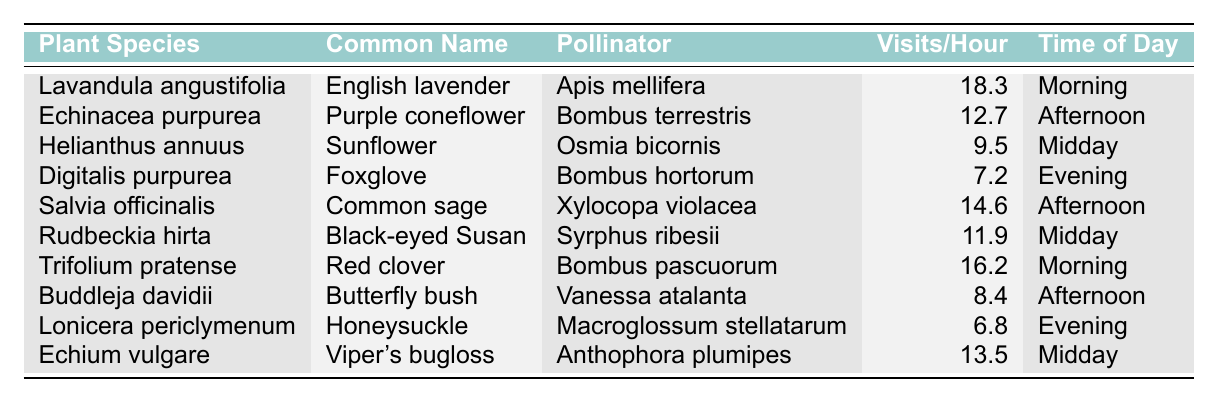What is the common name of the pollinator that visits Lavandula angustifolia? According to the table, the plant species Lavandula angustifolia, which is commonly known as English lavender, is visited by the pollinator Apis mellifera.
Answer: English lavender Which plant species has the highest visitation frequency? By examining the "Visits/Hour" column, Lavandula angustifolia has the highest value at 18.3 visits per hour.
Answer: Lavandula angustifolia How many visits per hour does Digitalis purpurea receive? The table lists Digitalis purpurea, or Foxglove, with a visitation frequency of 7.2 visits per hour.
Answer: 7.2 Are there any plants that are visited by Bombus species? The table indicates that both Echinacea purpurea (Bombus terrestris) and Trifolium pratense (Bombus pascuorum) are visited by Bombus species.
Answer: Yes What is the average number of visits per hour for the plants visited in the afternoon? The afternoon plants are Echinacea purpurea (12.7), Salvia officinalis (14.6), and Buddleja davidii (8.4). The sum is 12.7 + 14.6 + 8.4 = 35.7, and there are 3 plants, so the average is 35.7 / 3 = 11.9.
Answer: 11.9 Which time of day does Helianthus annuus receive pollinator visits? The table states that Helianthus annuus, or Sunflower, has pollinator visits recorded at midday.
Answer: Midday What is the difference in visitation frequency between Trifolium pratense and Digitalis purpurea? Trifolium pratense has 16.2 visits per hour and Digitalis purpurea has 7.2 visits per hour. The difference is calculated as 16.2 - 7.2 = 9.0.
Answer: 9.0 In the evening, which plant has the highest visitation frequency, and what is it? According to the table, Digitalis purpurea is the only specific plant listed for the evening with 7.2 visits per hour, thus it has the highest visitation frequency in that period.
Answer: Digitalis purpurea, 7.2 Does any plant have more than 15 visits per hour? The table shows that both Lavandula angustifolia (18.3) and Trifolium pratense (16.2) have more than 15 visits per hour.
Answer: Yes How many different pollinator species are listed in this table? The table lists six different pollinator species: Apis mellifera, Bombus terrestris, Osmia bicornis, Bombus hortorum, Xylocopa violacea, and Vanessa atalanta, among others. Counting them gives a total of seven.
Answer: Seven 